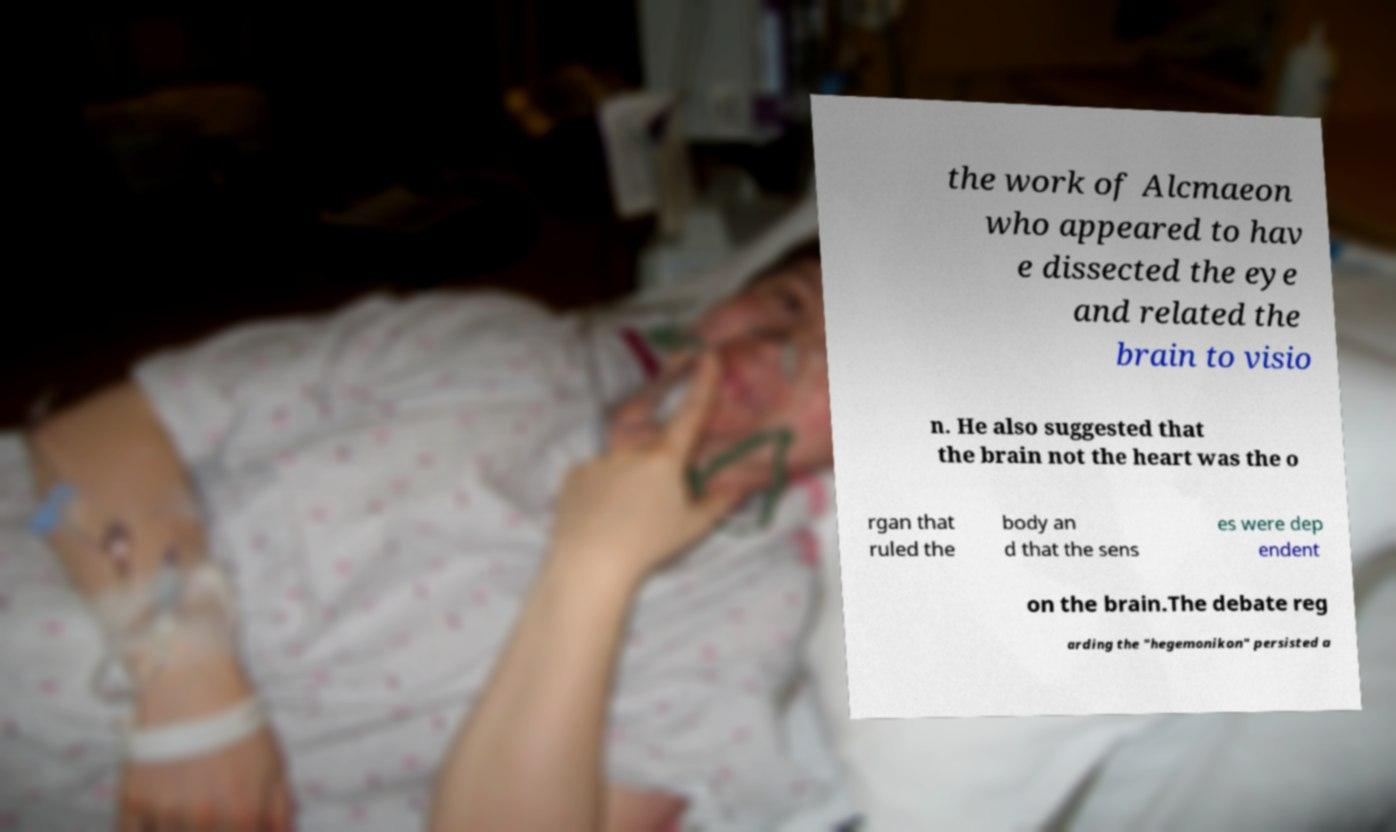Could you assist in decoding the text presented in this image and type it out clearly? the work of Alcmaeon who appeared to hav e dissected the eye and related the brain to visio n. He also suggested that the brain not the heart was the o rgan that ruled the body an d that the sens es were dep endent on the brain.The debate reg arding the "hegemonikon" persisted a 